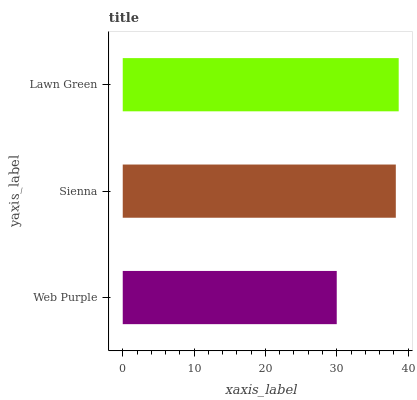Is Web Purple the minimum?
Answer yes or no. Yes. Is Lawn Green the maximum?
Answer yes or no. Yes. Is Sienna the minimum?
Answer yes or no. No. Is Sienna the maximum?
Answer yes or no. No. Is Sienna greater than Web Purple?
Answer yes or no. Yes. Is Web Purple less than Sienna?
Answer yes or no. Yes. Is Web Purple greater than Sienna?
Answer yes or no. No. Is Sienna less than Web Purple?
Answer yes or no. No. Is Sienna the high median?
Answer yes or no. Yes. Is Sienna the low median?
Answer yes or no. Yes. Is Lawn Green the high median?
Answer yes or no. No. Is Lawn Green the low median?
Answer yes or no. No. 